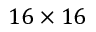<formula> <loc_0><loc_0><loc_500><loc_500>1 6 \times 1 6</formula> 